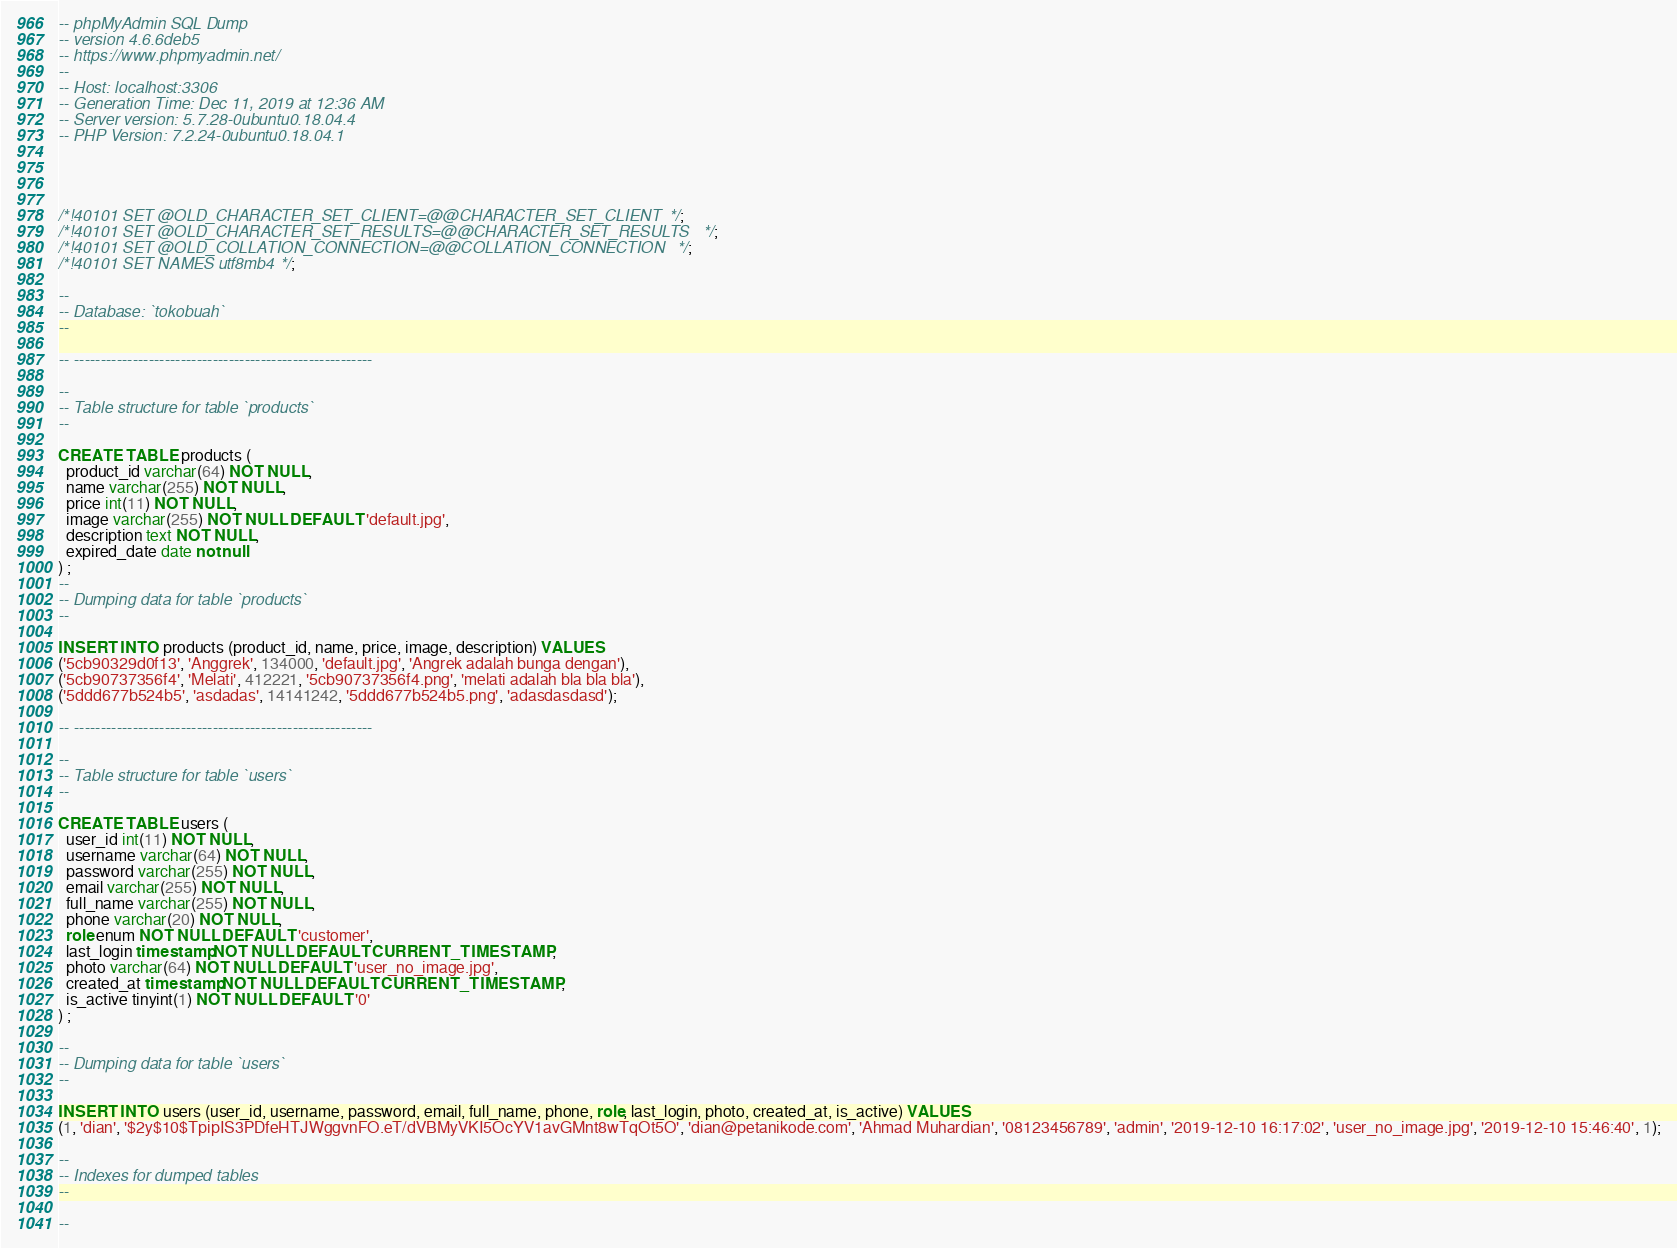Convert code to text. <code><loc_0><loc_0><loc_500><loc_500><_SQL_>-- phpMyAdmin SQL Dump
-- version 4.6.6deb5
-- https://www.phpmyadmin.net/
--
-- Host: localhost:3306
-- Generation Time: Dec 11, 2019 at 12:36 AM
-- Server version: 5.7.28-0ubuntu0.18.04.4
-- PHP Version: 7.2.24-0ubuntu0.18.04.1




/*!40101 SET @OLD_CHARACTER_SET_CLIENT=@@CHARACTER_SET_CLIENT */;
/*!40101 SET @OLD_CHARACTER_SET_RESULTS=@@CHARACTER_SET_RESULTS */;
/*!40101 SET @OLD_COLLATION_CONNECTION=@@COLLATION_CONNECTION */;
/*!40101 SET NAMES utf8mb4 */;

--
-- Database: `tokobuah`
--

-- --------------------------------------------------------

--
-- Table structure for table `products`
--

CREATE TABLE products (
  product_id varchar(64) NOT NULL,
  name varchar(255) NOT NULL,
  price int(11) NOT NULL,
  image varchar(255) NOT NULL DEFAULT 'default.jpg',
  description text NOT NULL,
  expired_date date not null
) ;
--
-- Dumping data for table `products`
--

INSERT INTO products (product_id, name, price, image, description) VALUES
('5cb90329d0f13', 'Anggrek', 134000, 'default.jpg', 'Angrek adalah bunga dengan'),
('5cb90737356f4', 'Melati', 412221, '5cb90737356f4.png', 'melati adalah bla bla bla'),
('5ddd677b524b5', 'asdadas', 14141242, '5ddd677b524b5.png', 'adasdasdasd');

-- --------------------------------------------------------

--
-- Table structure for table `users`
--

CREATE TABLE users (
  user_id int(11) NOT NULL,
  username varchar(64) NOT NULL,
  password varchar(255) NOT NULL,
  email varchar(255) NOT NULL,
  full_name varchar(255) NOT NULL,
  phone varchar(20) NOT NULL,
  role enum NOT NULL DEFAULT 'customer',
  last_login timestamp NOT NULL DEFAULT CURRENT_TIMESTAMP,
  photo varchar(64) NOT NULL DEFAULT 'user_no_image.jpg',
  created_at timestamp NOT NULL DEFAULT CURRENT_TIMESTAMP,
  is_active tinyint(1) NOT NULL DEFAULT '0'
) ;

--
-- Dumping data for table `users`
--

INSERT INTO users (user_id, username, password, email, full_name, phone, role, last_login, photo, created_at, is_active) VALUES
(1, 'dian', '$2y$10$TpipIS3PDfeHTJWggvnFO.eT/dVBMyVKI5OcYV1avGMnt8wTqOt5O', 'dian@petanikode.com', 'Ahmad Muhardian', '08123456789', 'admin', '2019-12-10 16:17:02', 'user_no_image.jpg', '2019-12-10 15:46:40', 1);

--
-- Indexes for dumped tables
--

--</code> 